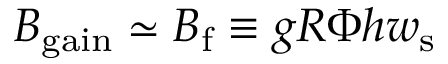Convert formula to latex. <formula><loc_0><loc_0><loc_500><loc_500>B _ { g a i n } \simeq B _ { f } \equiv g R \Phi h w _ { s }</formula> 